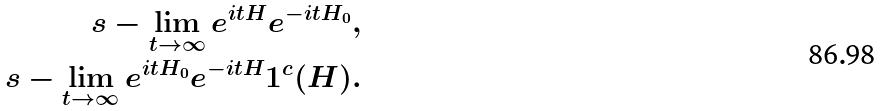<formula> <loc_0><loc_0><loc_500><loc_500>s - \lim _ { t \rightarrow \infty } e ^ { i t H } e ^ { - i t H _ { 0 } } , \\ s - \lim _ { t \rightarrow \infty } e ^ { i t H _ { 0 } } e ^ { - i t H } { 1 } ^ { c } ( H ) .</formula> 